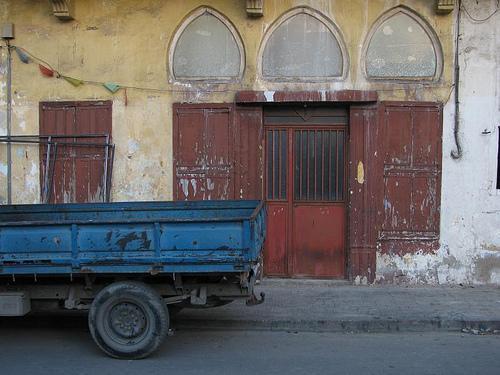How many people with hats are there?
Give a very brief answer. 0. 